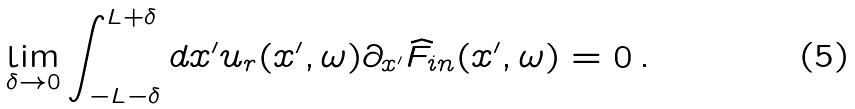<formula> <loc_0><loc_0><loc_500><loc_500>\lim _ { \delta \rightarrow 0 } \int _ { - L - \delta } ^ { L + \delta } d x ^ { \prime } u _ { r } ( x ^ { \prime } , \omega ) \partial _ { x ^ { \prime } } \widehat { F } _ { i n } ( x ^ { \prime } , \omega ) = 0 \, .</formula> 